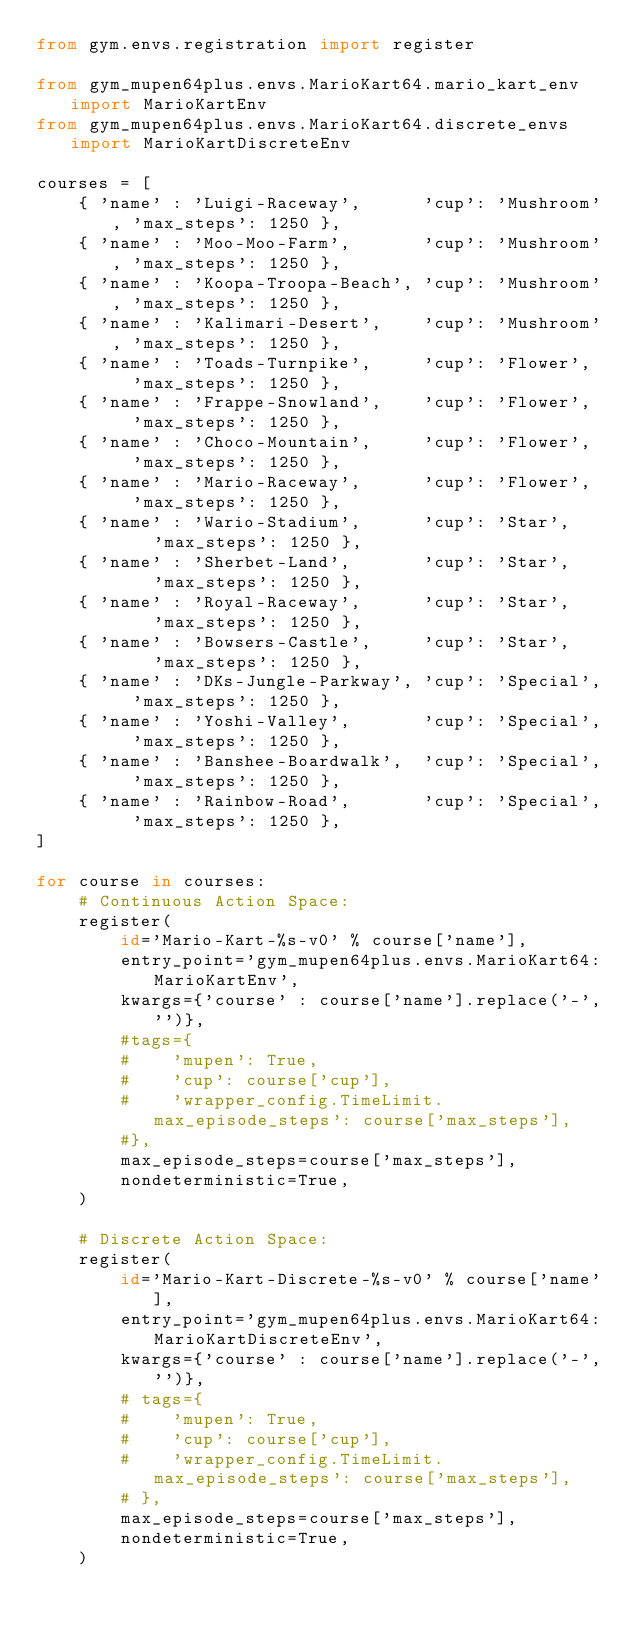<code> <loc_0><loc_0><loc_500><loc_500><_Python_>from gym.envs.registration import register

from gym_mupen64plus.envs.MarioKart64.mario_kart_env import MarioKartEnv
from gym_mupen64plus.envs.MarioKart64.discrete_envs import MarioKartDiscreteEnv

courses = [
    { 'name' : 'Luigi-Raceway',      'cup': 'Mushroom', 'max_steps': 1250 },
    { 'name' : 'Moo-Moo-Farm',       'cup': 'Mushroom', 'max_steps': 1250 },
    { 'name' : 'Koopa-Troopa-Beach', 'cup': 'Mushroom', 'max_steps': 1250 },
    { 'name' : 'Kalimari-Desert',    'cup': 'Mushroom', 'max_steps': 1250 },
    { 'name' : 'Toads-Turnpike',     'cup': 'Flower',   'max_steps': 1250 },
    { 'name' : 'Frappe-Snowland',    'cup': 'Flower',   'max_steps': 1250 },
    { 'name' : 'Choco-Mountain',     'cup': 'Flower',   'max_steps': 1250 },
    { 'name' : 'Mario-Raceway',      'cup': 'Flower',   'max_steps': 1250 },
    { 'name' : 'Wario-Stadium',      'cup': 'Star',     'max_steps': 1250 },
    { 'name' : 'Sherbet-Land',       'cup': 'Star',     'max_steps': 1250 },
    { 'name' : 'Royal-Raceway',      'cup': 'Star',     'max_steps': 1250 },
    { 'name' : 'Bowsers-Castle',     'cup': 'Star',     'max_steps': 1250 },
    { 'name' : 'DKs-Jungle-Parkway', 'cup': 'Special',  'max_steps': 1250 },
    { 'name' : 'Yoshi-Valley',       'cup': 'Special',  'max_steps': 1250 },
    { 'name' : 'Banshee-Boardwalk',  'cup': 'Special',  'max_steps': 1250 },
    { 'name' : 'Rainbow-Road',       'cup': 'Special',  'max_steps': 1250 },
]

for course in courses:
    # Continuous Action Space:
    register(
        id='Mario-Kart-%s-v0' % course['name'],
        entry_point='gym_mupen64plus.envs.MarioKart64:MarioKartEnv',
        kwargs={'course' : course['name'].replace('-','')},
        #tags={
        #    'mupen': True,
        #    'cup': course['cup'],
        #    'wrapper_config.TimeLimit.max_episode_steps': course['max_steps'],
        #},
        max_episode_steps=course['max_steps'],
        nondeterministic=True,
    )

    # Discrete Action Space:
    register(
        id='Mario-Kart-Discrete-%s-v0' % course['name'],
        entry_point='gym_mupen64plus.envs.MarioKart64:MarioKartDiscreteEnv',
        kwargs={'course' : course['name'].replace('-','')},
        # tags={
        #    'mupen': True,
        #    'cup': course['cup'],
        #    'wrapper_config.TimeLimit.max_episode_steps': course['max_steps'],
        # },
        max_episode_steps=course['max_steps'],
        nondeterministic=True,
    )
</code> 